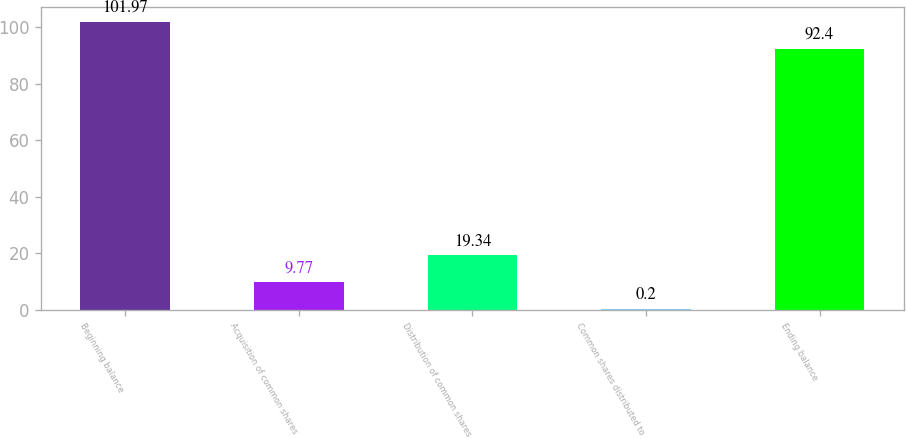Convert chart. <chart><loc_0><loc_0><loc_500><loc_500><bar_chart><fcel>Beginning balance<fcel>Acquisition of common shares<fcel>Distribution of common shares<fcel>Common shares distributed to<fcel>Ending balance<nl><fcel>101.97<fcel>9.77<fcel>19.34<fcel>0.2<fcel>92.4<nl></chart> 